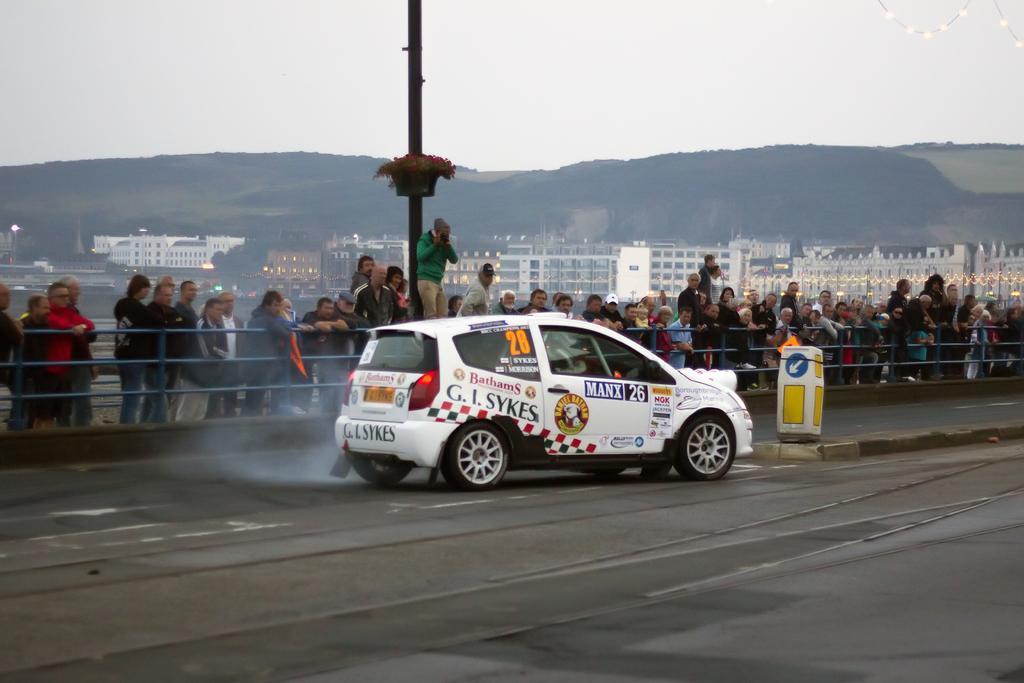Can you describe this image briefly? In the center of the image, we can see a car on the road and there is a board. In the background, we can see people and some are wearing caps and holding objects and we can see buildings, trees, hills, lights and railings. At the top, there is sky. 